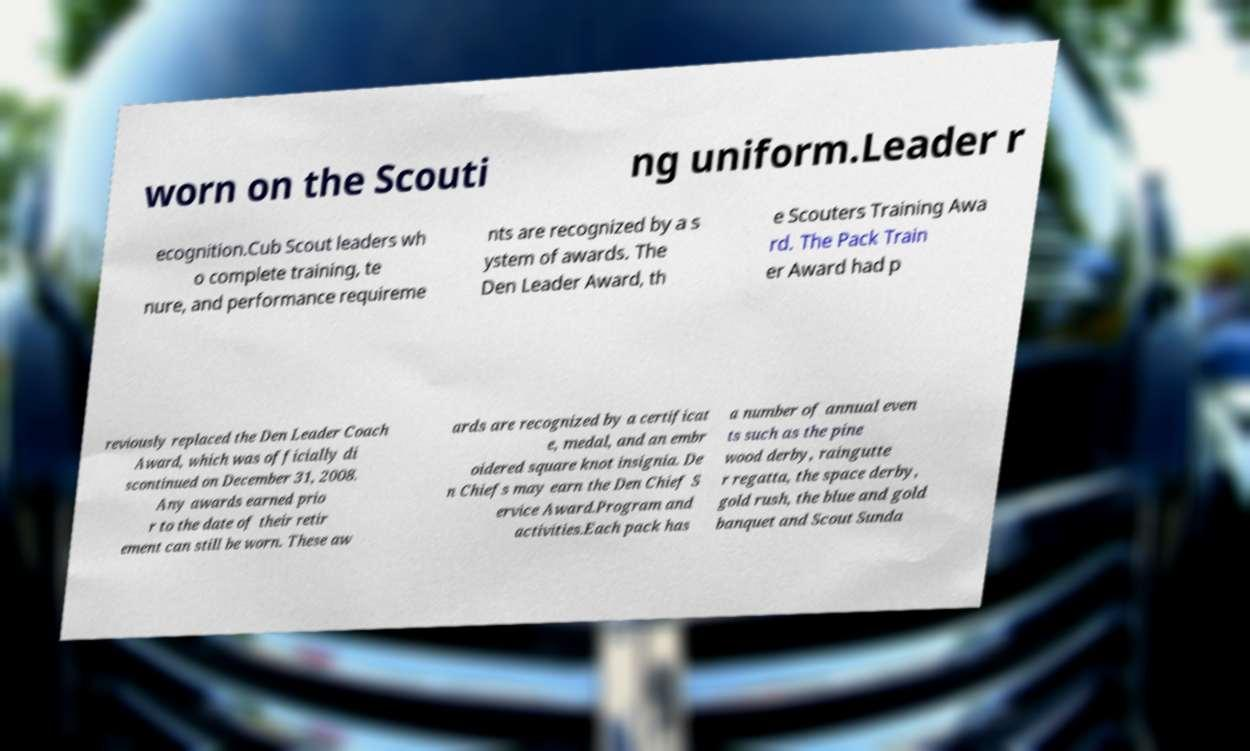Can you read and provide the text displayed in the image?This photo seems to have some interesting text. Can you extract and type it out for me? worn on the Scouti ng uniform.Leader r ecognition.Cub Scout leaders wh o complete training, te nure, and performance requireme nts are recognized by a s ystem of awards. The Den Leader Award, th e Scouters Training Awa rd. The Pack Train er Award had p reviously replaced the Den Leader Coach Award, which was officially di scontinued on December 31, 2008. Any awards earned prio r to the date of their retir ement can still be worn. These aw ards are recognized by a certificat e, medal, and an embr oidered square knot insignia. De n Chiefs may earn the Den Chief S ervice Award.Program and activities.Each pack has a number of annual even ts such as the pine wood derby, raingutte r regatta, the space derby, gold rush, the blue and gold banquet and Scout Sunda 